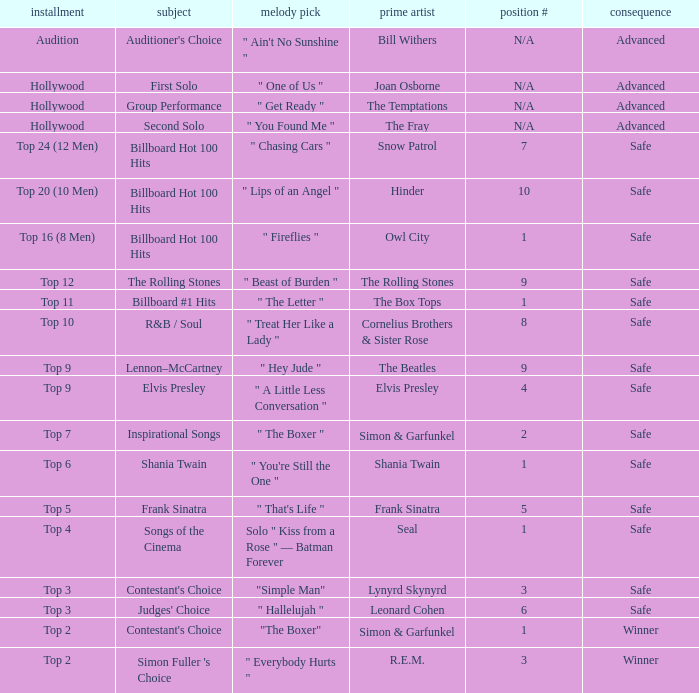The song choice " One of Us " has what themes? First Solo. 